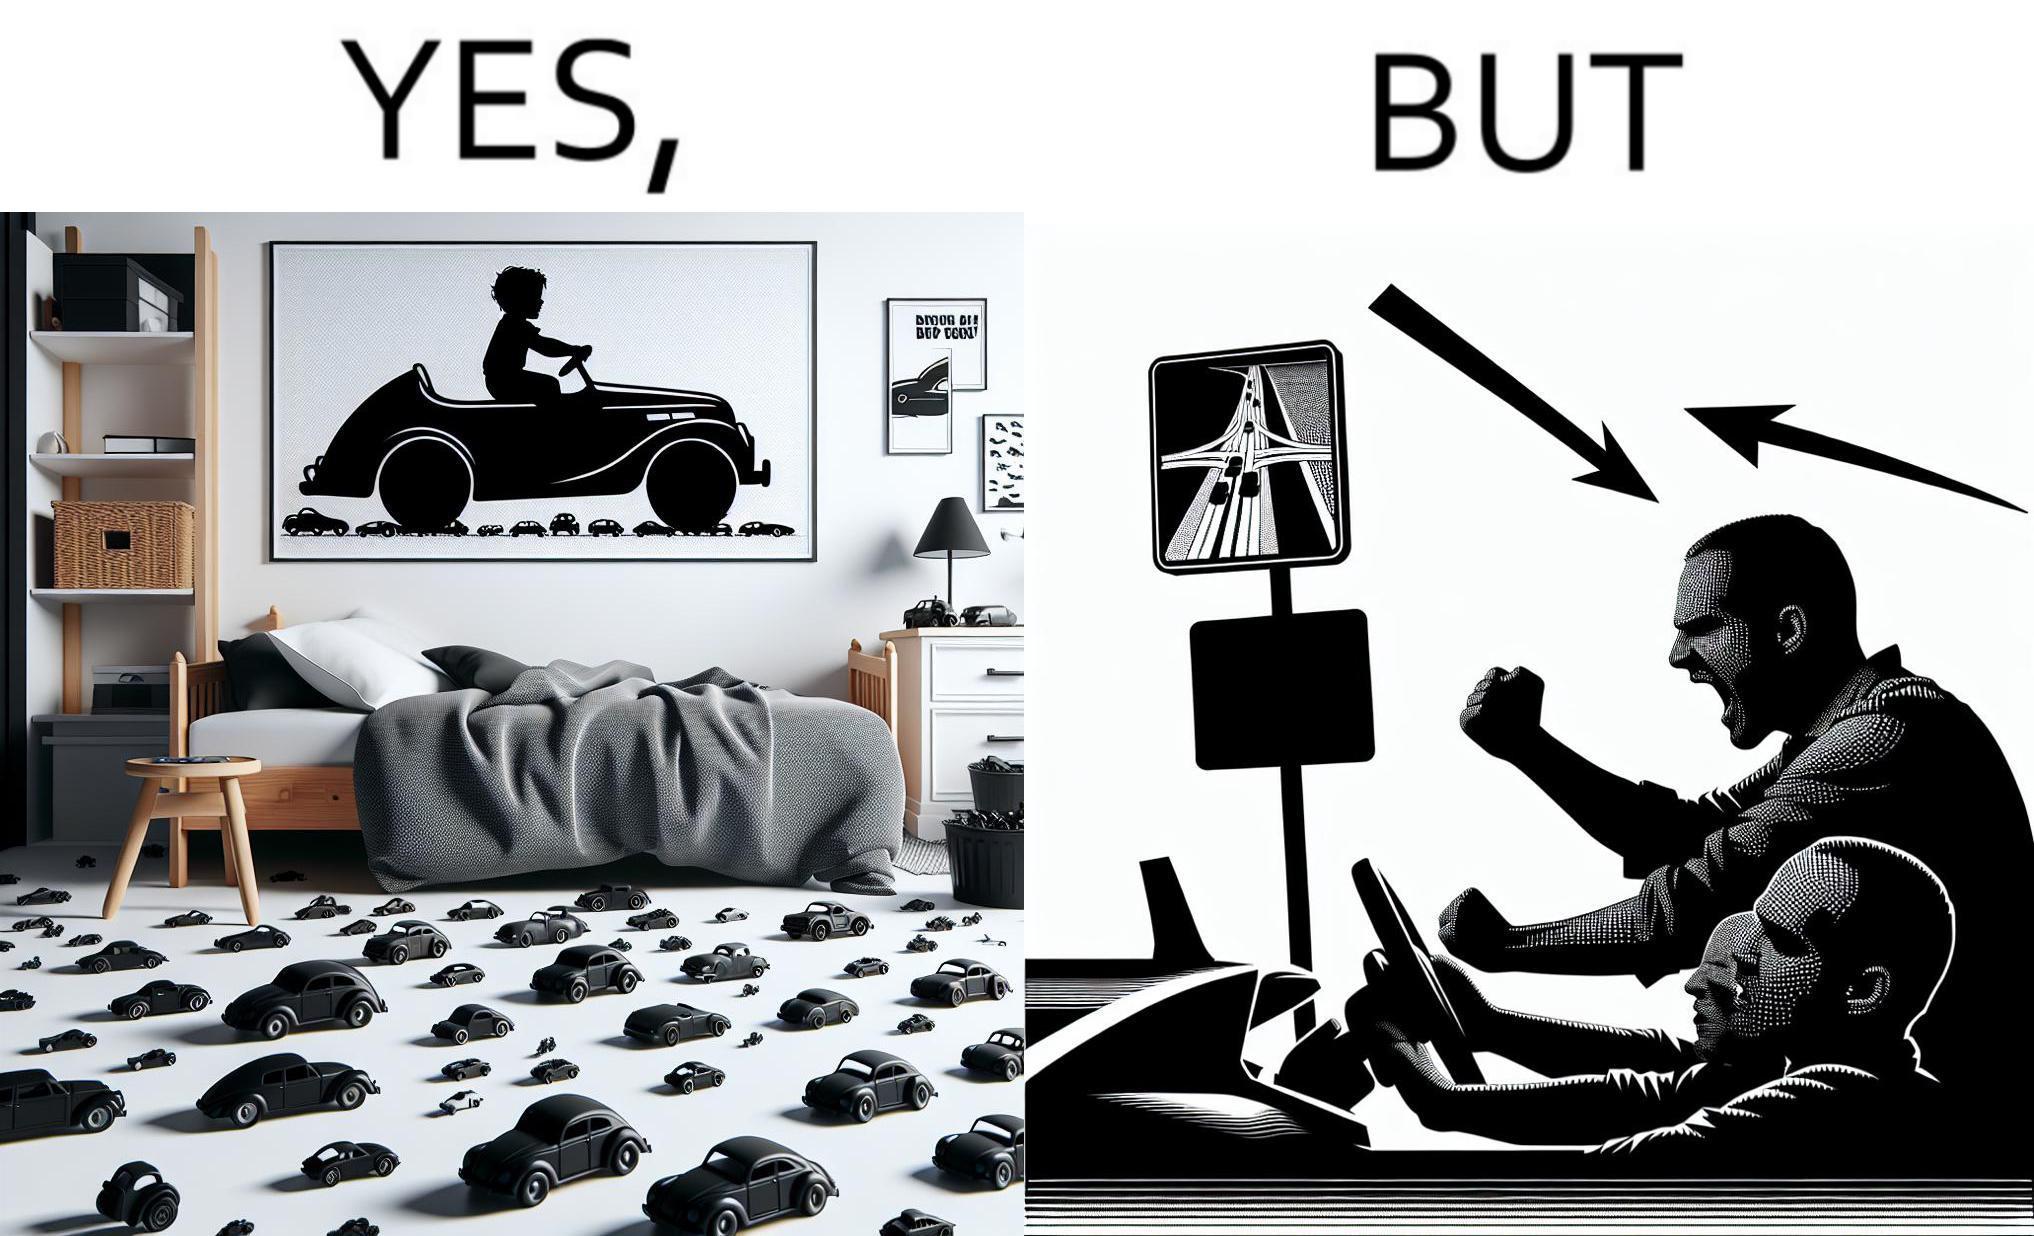What does this image depict? The image is funny beaucse while the person as a child enjoyed being around cars, had various small toy cars and even rode a bigger toy car, as as grown up he does not enjoy being in a car during a traffic jam while he is driving . 